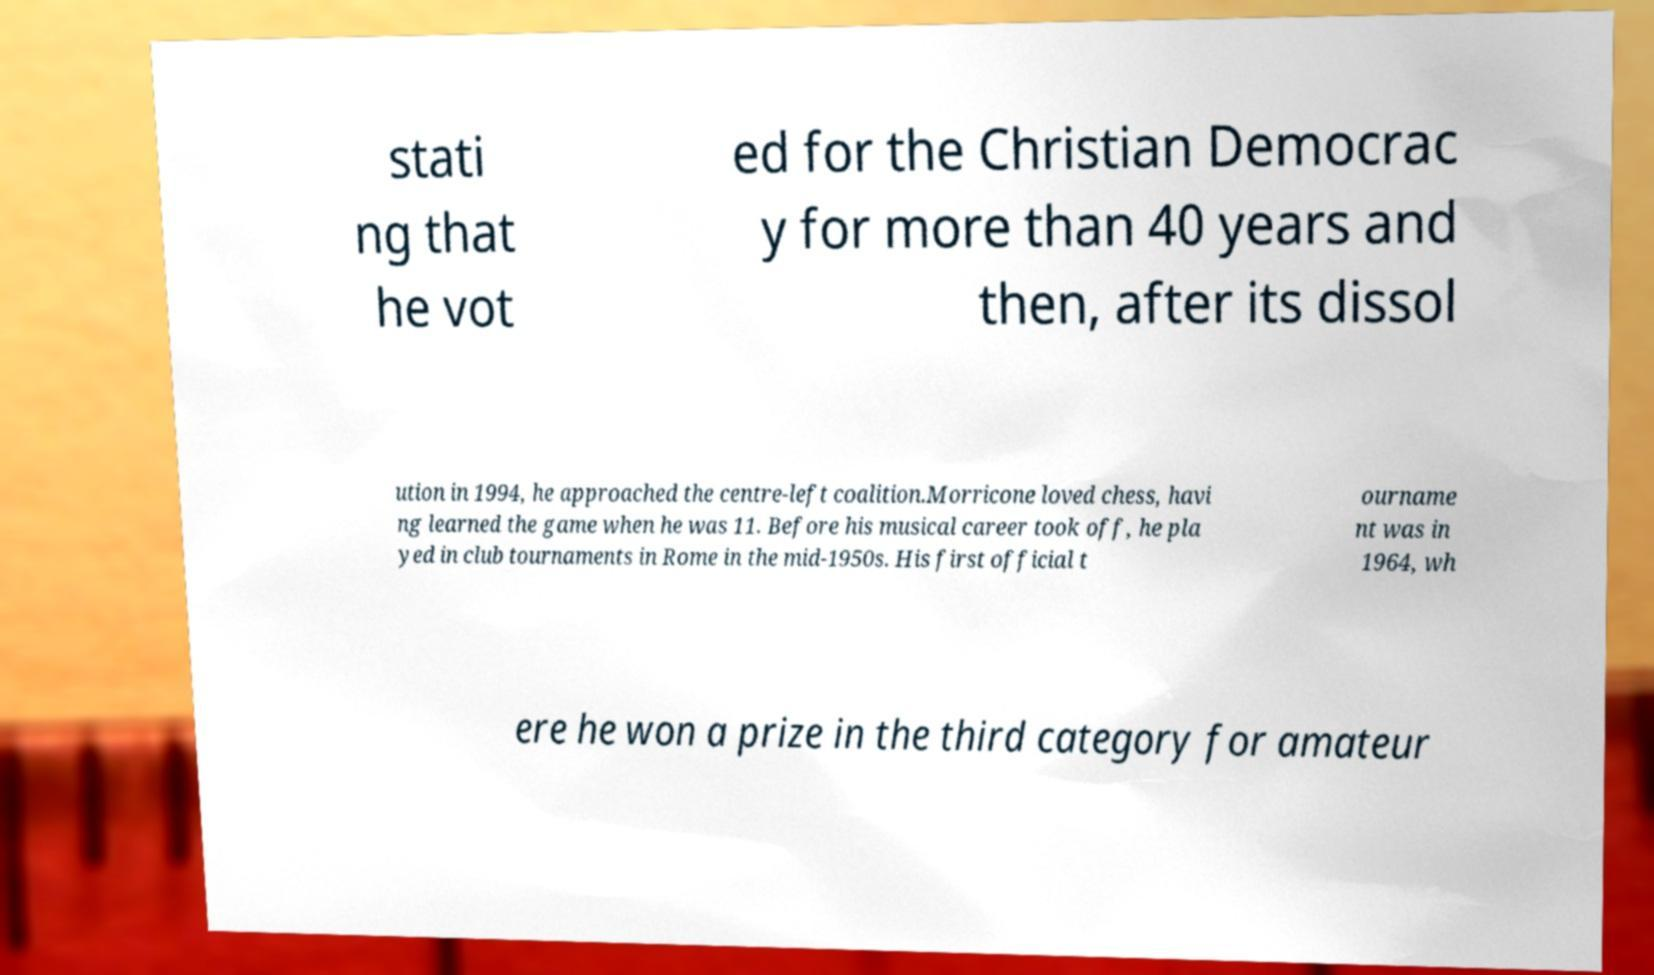Could you extract and type out the text from this image? stati ng that he vot ed for the Christian Democrac y for more than 40 years and then, after its dissol ution in 1994, he approached the centre-left coalition.Morricone loved chess, havi ng learned the game when he was 11. Before his musical career took off, he pla yed in club tournaments in Rome in the mid-1950s. His first official t ourname nt was in 1964, wh ere he won a prize in the third category for amateur 